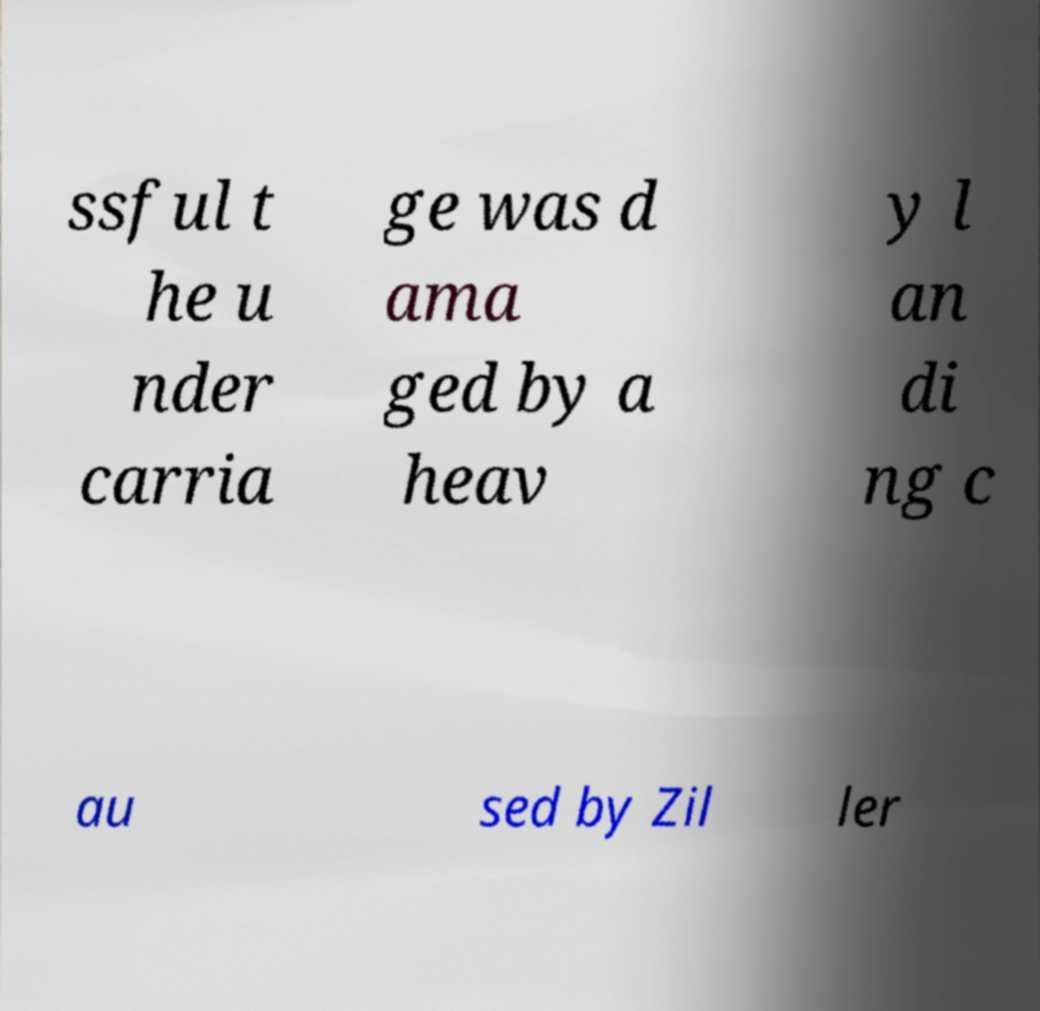Please identify and transcribe the text found in this image. ssful t he u nder carria ge was d ama ged by a heav y l an di ng c au sed by Zil ler 